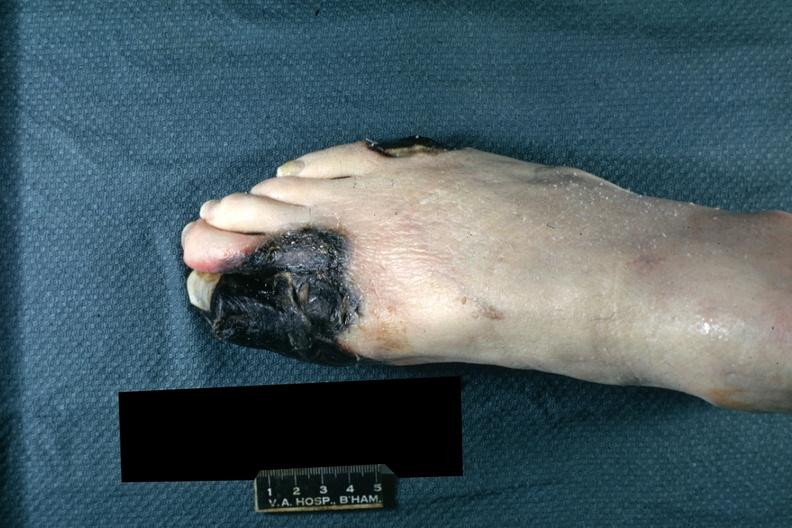re extremities present?
Answer the question using a single word or phrase. Yes 